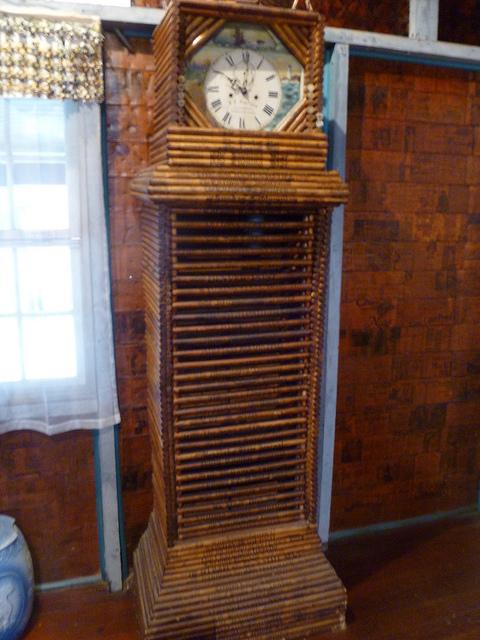What time is shown on the clock?
Write a very short answer. 10:00. What color are the curtains?
Short answer required. White. Was this photo taken in the morning?
Write a very short answer. Yes. How much longer until it will be midnight?
Write a very short answer. 2 hours. Are the walls painted?
Concise answer only. Yes. What is the clock made of?
Short answer required. Wood. Does the clock match the decor?
Write a very short answer. Yes. What is the wall made of?
Be succinct. Wood. How many clocks are there?
Be succinct. 1. Is the face of the clock the same color as the wall?
Answer briefly. No. What is this scene made of?
Quick response, please. Wood. 